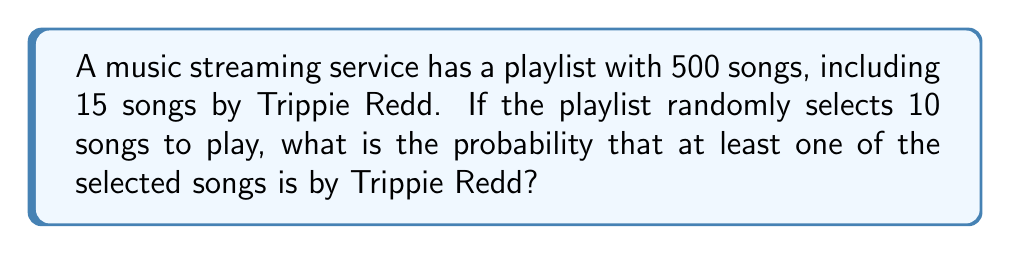Show me your answer to this math problem. To solve this problem, we'll use the complementary probability approach:

1) First, let's calculate the probability of not selecting any Trippie Redd songs.

2) The total number of ways to select 10 songs out of 500 is $\binom{500}{10}$.

3) The number of ways to select 10 songs that are not by Trippie Redd is $\binom{485}{10}$, as there are 485 non-Trippie Redd songs (500 - 15 = 485).

4) The probability of not selecting any Trippie Redd songs is:

   $$P(\text{no Trippie Redd}) = \frac{\binom{485}{10}}{\binom{500}{10}}$$

5) Therefore, the probability of selecting at least one Trippie Redd song is:

   $$P(\text{at least one Trippie Redd}) = 1 - P(\text{no Trippie Redd})$$

   $$= 1 - \frac{\binom{485}{10}}{\binom{500}{10}}$$

6) Calculating this:

   $$= 1 - \frac{485!/(475! \cdot 10!)}{500!/(490! \cdot 10!)}$$
   
   $$= 1 - \frac{485 \cdot 484 \cdot 483 \cdot 482 \cdot 481 \cdot 480 \cdot 479 \cdot 478 \cdot 477 \cdot 476}{500 \cdot 499 \cdot 498 \cdot 497 \cdot 496 \cdot 495 \cdot 494 \cdot 493 \cdot 492 \cdot 491}$$

7) Using a calculator or computer, we can evaluate this expression.
Answer: The probability of hearing at least one Trippie Redd song is approximately 0.2642 or 26.42%. 